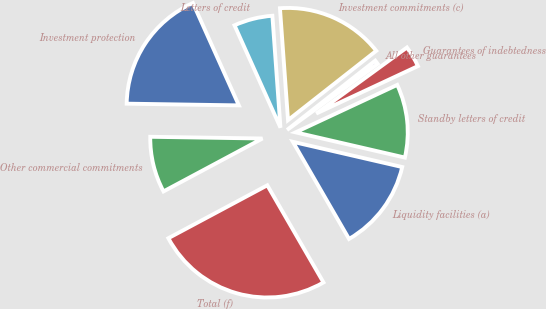<chart> <loc_0><loc_0><loc_500><loc_500><pie_chart><fcel>Liquidity facilities (a)<fcel>Standby letters of credit<fcel>Guarantees of indebtedness<fcel>All other guarantees<fcel>Investment commitments (c)<fcel>Letters of credit<fcel>Investment protection<fcel>Other commercial commitments<fcel>Total (f)<nl><fcel>13.05%<fcel>10.56%<fcel>3.07%<fcel>0.58%<fcel>15.55%<fcel>5.57%<fcel>18.04%<fcel>8.06%<fcel>25.53%<nl></chart> 